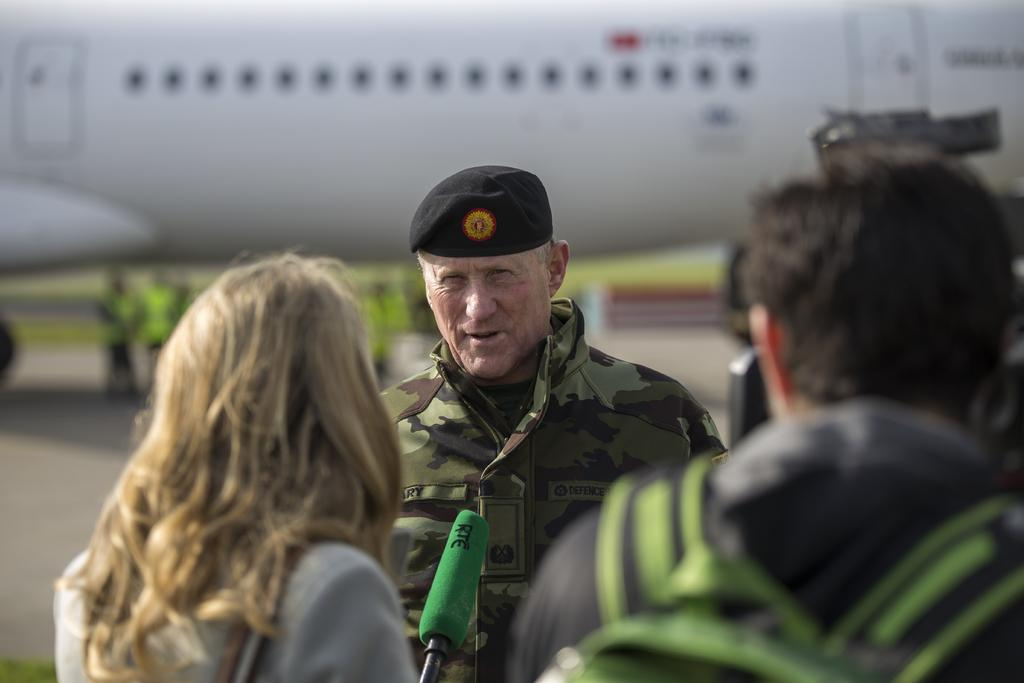How many people are visible in the image? There are three people standing in the image. What is the woman holding in the image? The woman is holding a microphone. What can be seen behind the people in the image? There is an airplane behind the people. Can you describe the people in the background of the image? There are blurred people standing on a path in the background. What type of crack is visible on the ship in the image? There is no ship present in the image, and therefore no crack can be observed. 